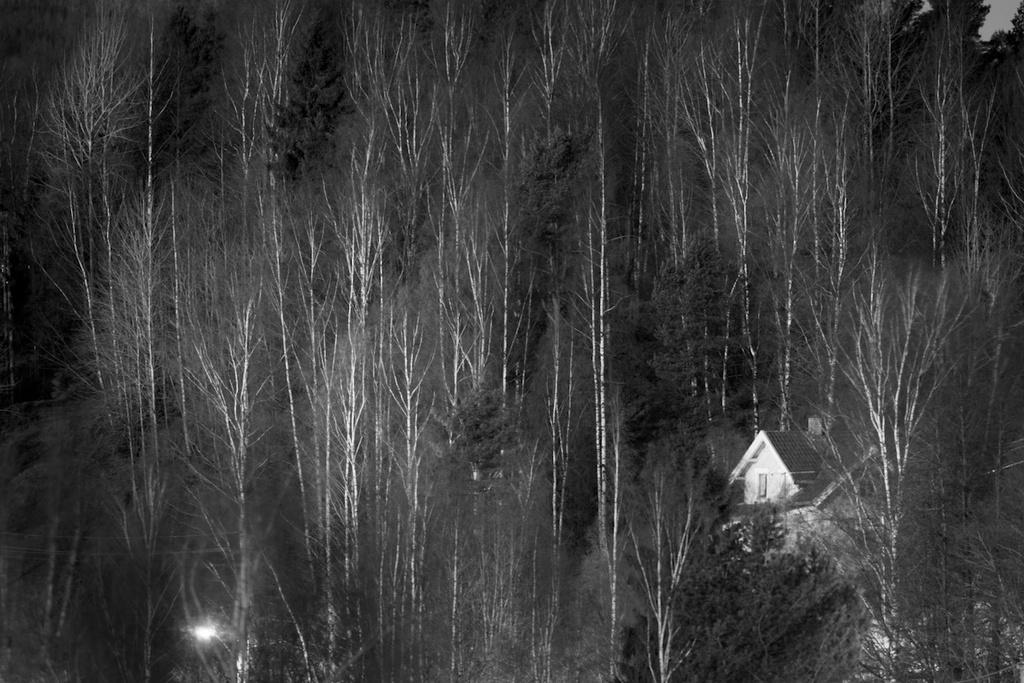What type of vegetation can be seen in the picture? There are trees in the picture. What type of structure is present in the picture? There is a house in the picture. What is the color scheme of the picture? The picture is black and white in color. What type of coat is the tree wearing in the picture? There is no coat present in the picture, as trees do not wear clothing. What time of day is depicted in the image based on the presence of a watch? There is no watch present in the image, so it is not possible to determine the time of day. 